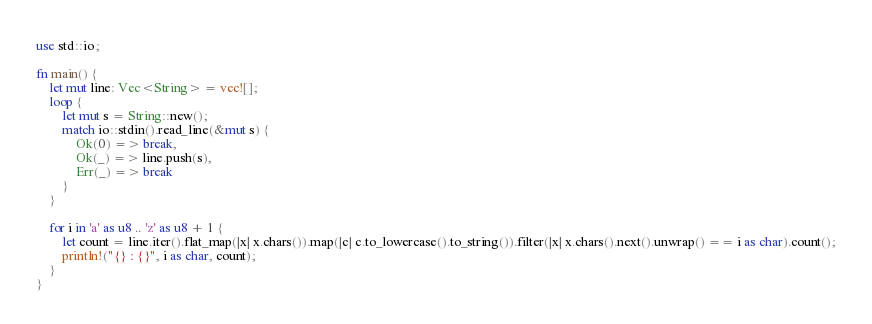Convert code to text. <code><loc_0><loc_0><loc_500><loc_500><_Rust_>use std::io;

fn main() {
    let mut line: Vec<String> = vec![];
    loop {
        let mut s = String::new();
        match io::stdin().read_line(&mut s) {
            Ok(0) => break,
            Ok(_) => line.push(s),
            Err(_) => break
        }
    }

    for i in 'a' as u8 .. 'z' as u8 + 1 {
        let count = line.iter().flat_map(|x| x.chars()).map(|c| c.to_lowercase().to_string()).filter(|x| x.chars().next().unwrap() == i as char).count();
        println!("{} : {}", i as char, count);
    }
}
</code> 